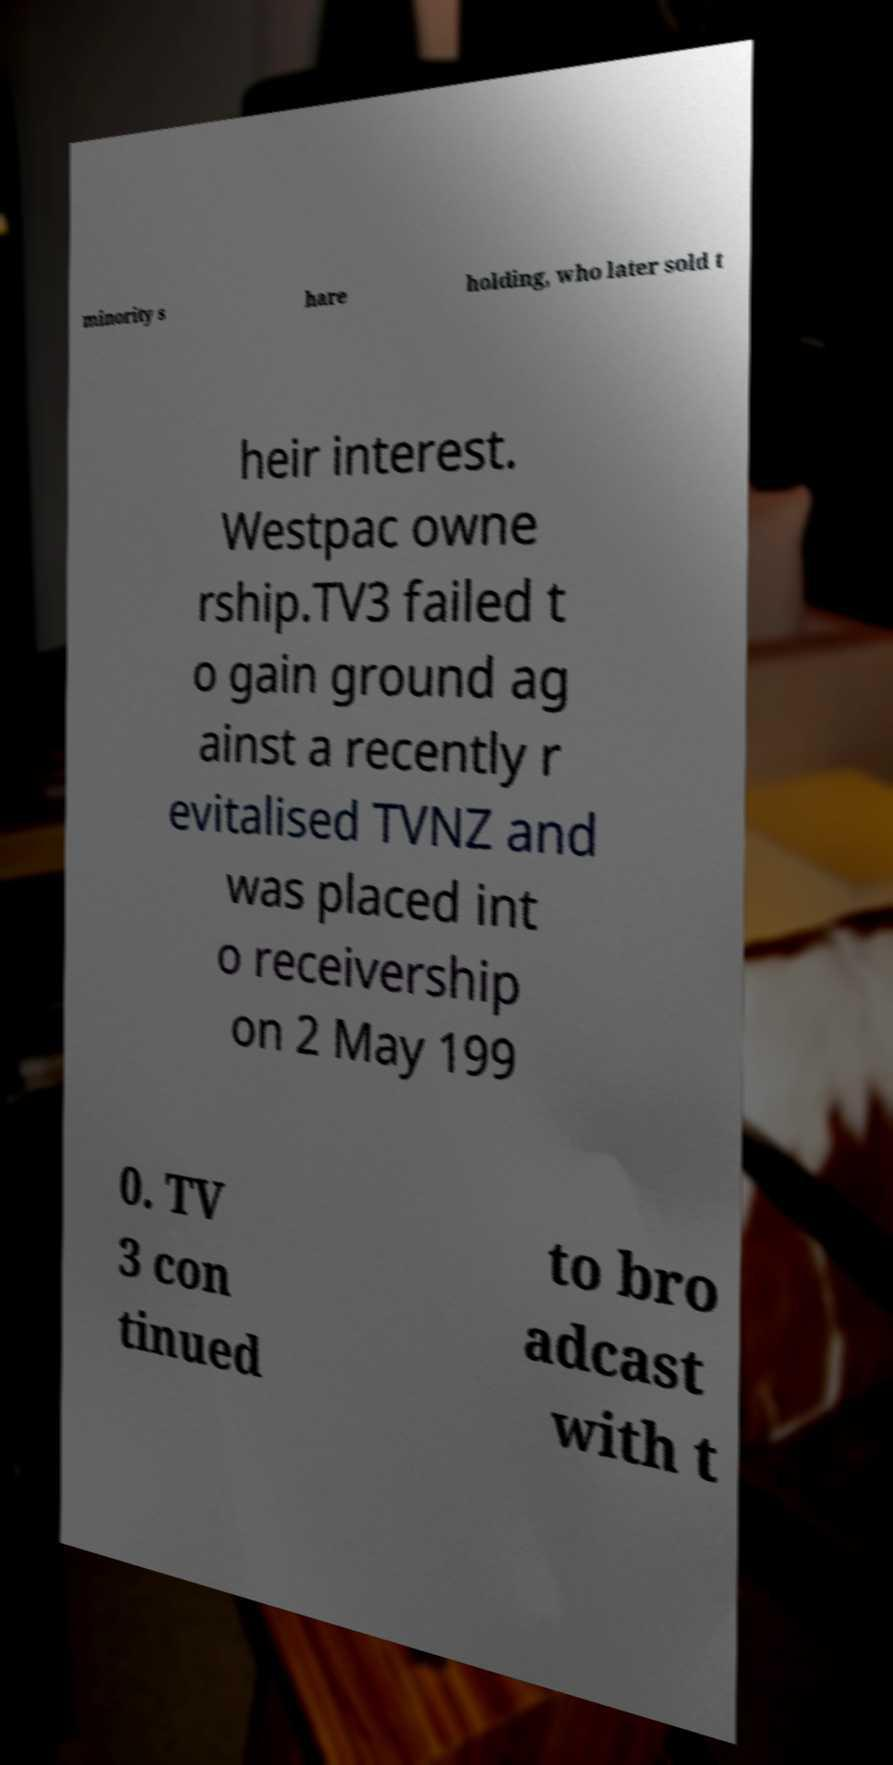Can you accurately transcribe the text from the provided image for me? minority s hare holding, who later sold t heir interest. Westpac owne rship.TV3 failed t o gain ground ag ainst a recently r evitalised TVNZ and was placed int o receivership on 2 May 199 0. TV 3 con tinued to bro adcast with t 